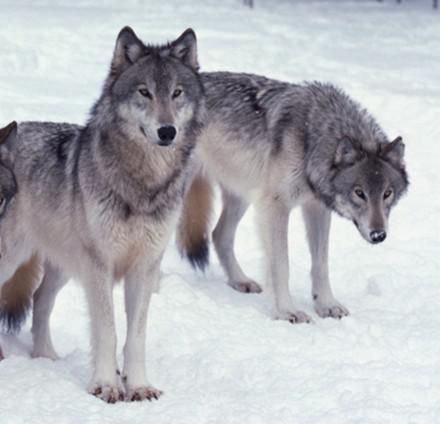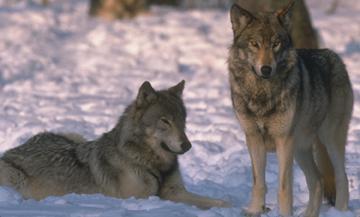The first image is the image on the left, the second image is the image on the right. For the images displayed, is the sentence "There are two wolves in the right image." factually correct? Answer yes or no. Yes. The first image is the image on the left, the second image is the image on the right. Analyze the images presented: Is the assertion "there are wolves with teeth bared in a snarl" valid? Answer yes or no. No. 